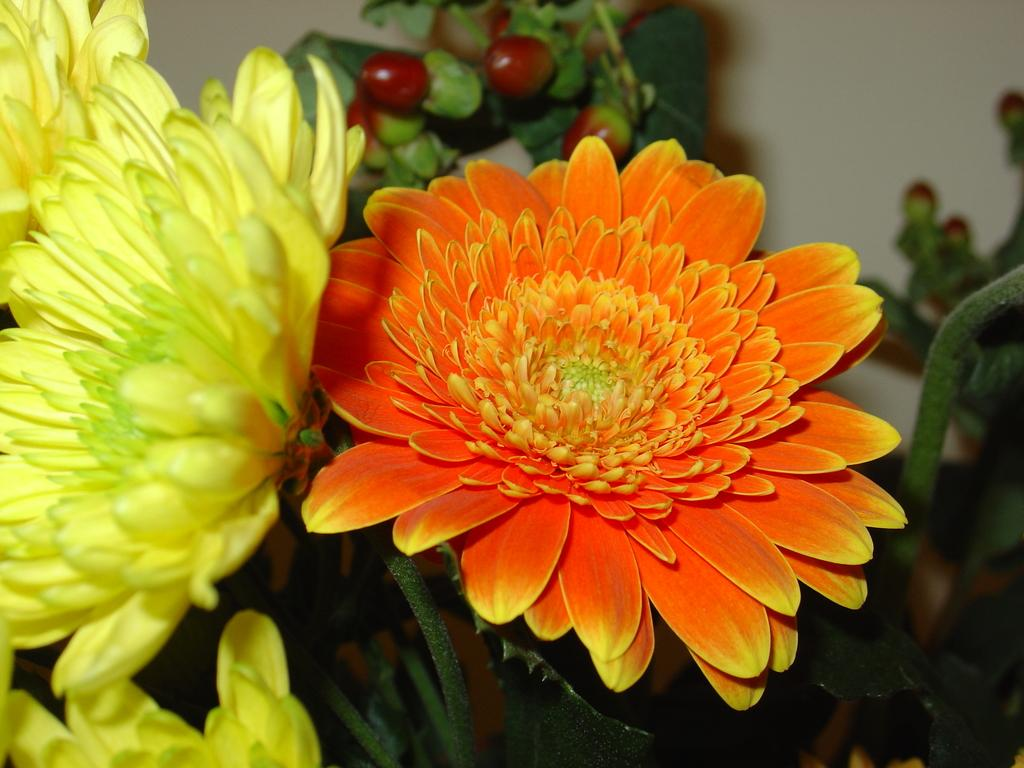What type of plant life is visible in the image? There are stems with flowers and leaves in the image. Are there any other plant-related items visible in the image? Yes, there are fruits in the image. What can be seen in the background of the image? There is a wall in the background of the image. Can you see a quill being used to write on the wall in the image? No, there is no quill or writing on the wall in the image. Is there a fireman present in the image? No, there is no fireman in the image. 